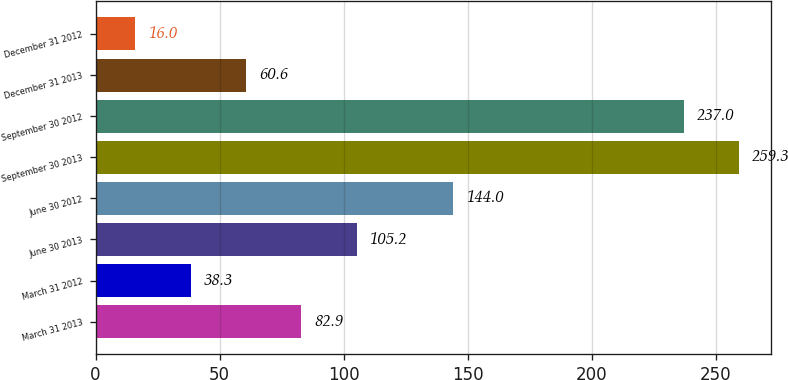Convert chart to OTSL. <chart><loc_0><loc_0><loc_500><loc_500><bar_chart><fcel>March 31 2013<fcel>March 31 2012<fcel>June 30 2013<fcel>June 30 2012<fcel>September 30 2013<fcel>September 30 2012<fcel>December 31 2013<fcel>December 31 2012<nl><fcel>82.9<fcel>38.3<fcel>105.2<fcel>144<fcel>259.3<fcel>237<fcel>60.6<fcel>16<nl></chart> 